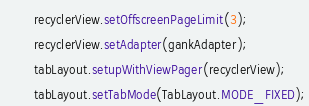Convert code to text. <code><loc_0><loc_0><loc_500><loc_500><_Java_>        recyclerView.setOffscreenPageLimit(3);
        recyclerView.setAdapter(gankAdapter);
        tabLayout.setupWithViewPager(recyclerView);
        tabLayout.setTabMode(TabLayout.MODE_FIXED);</code> 